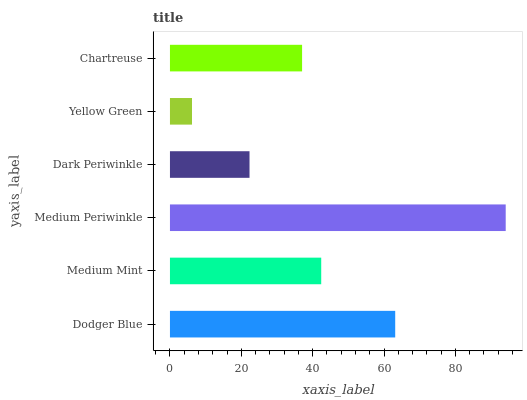Is Yellow Green the minimum?
Answer yes or no. Yes. Is Medium Periwinkle the maximum?
Answer yes or no. Yes. Is Medium Mint the minimum?
Answer yes or no. No. Is Medium Mint the maximum?
Answer yes or no. No. Is Dodger Blue greater than Medium Mint?
Answer yes or no. Yes. Is Medium Mint less than Dodger Blue?
Answer yes or no. Yes. Is Medium Mint greater than Dodger Blue?
Answer yes or no. No. Is Dodger Blue less than Medium Mint?
Answer yes or no. No. Is Medium Mint the high median?
Answer yes or no. Yes. Is Chartreuse the low median?
Answer yes or no. Yes. Is Dark Periwinkle the high median?
Answer yes or no. No. Is Yellow Green the low median?
Answer yes or no. No. 